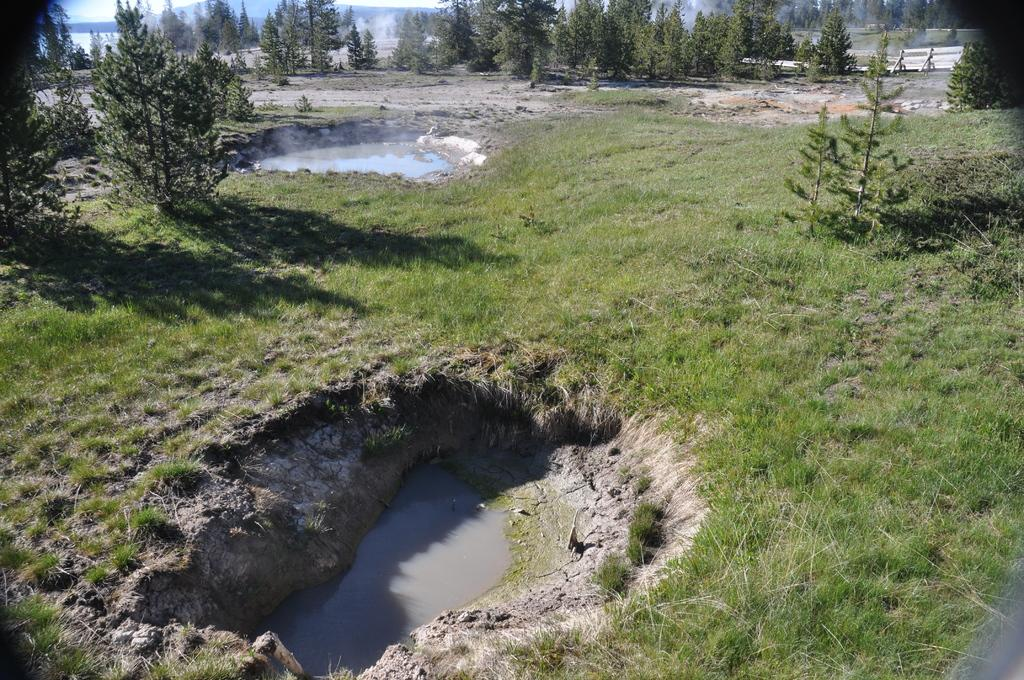What type of surface is on the ground in the image? There is grass on the ground in the image. What can be found in the ponds in the image? There is water in the ponds in the image. What type of vegetation is visible in the background of the image? There are plants and trees visible in the background of the image. What else can be seen in the background of the image? There are other objects visible in the background of the image. How many geese are swimming in the ponds in the image? There are no geese visible in the image; only water can be seen in the ponds. What type of material is the brick wall made of in the image? There is no brick wall present in the image. 